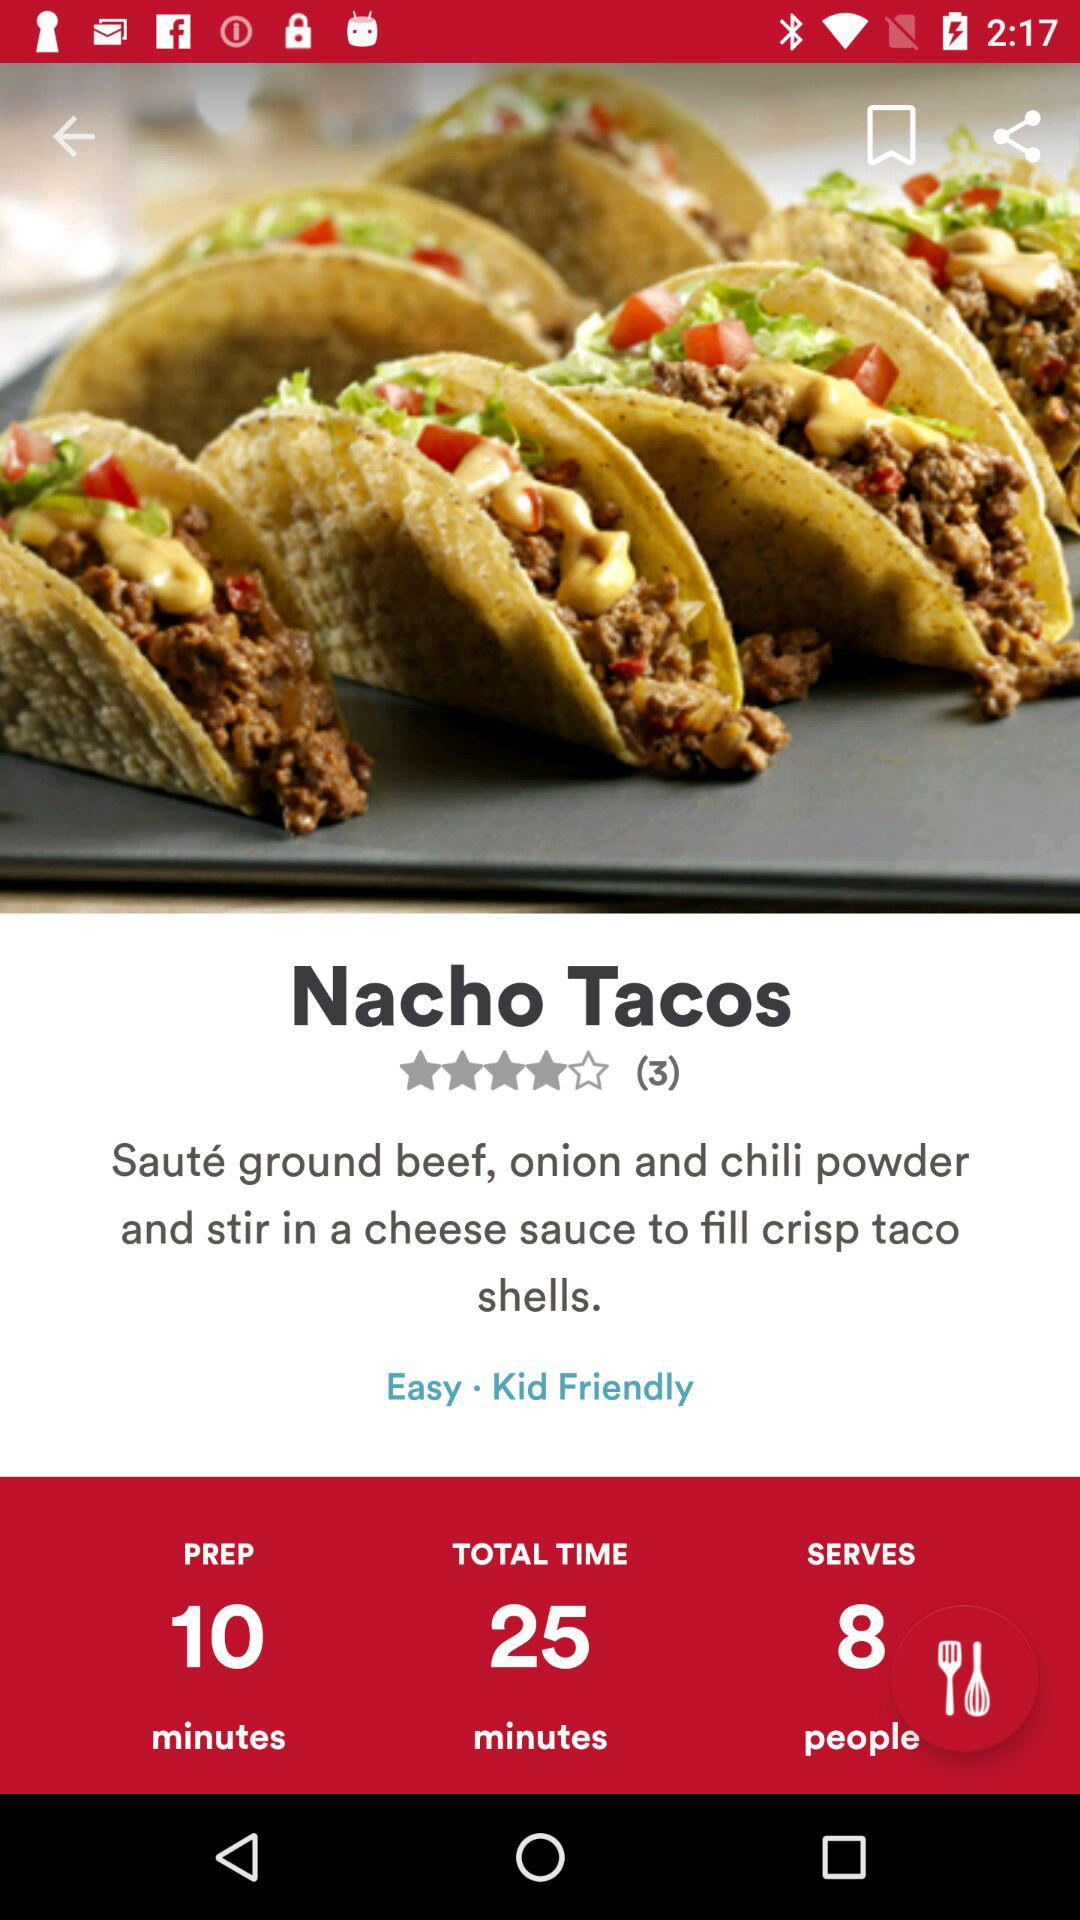How many people can this recipe serve?
Answer the question using a single word or phrase. 8 